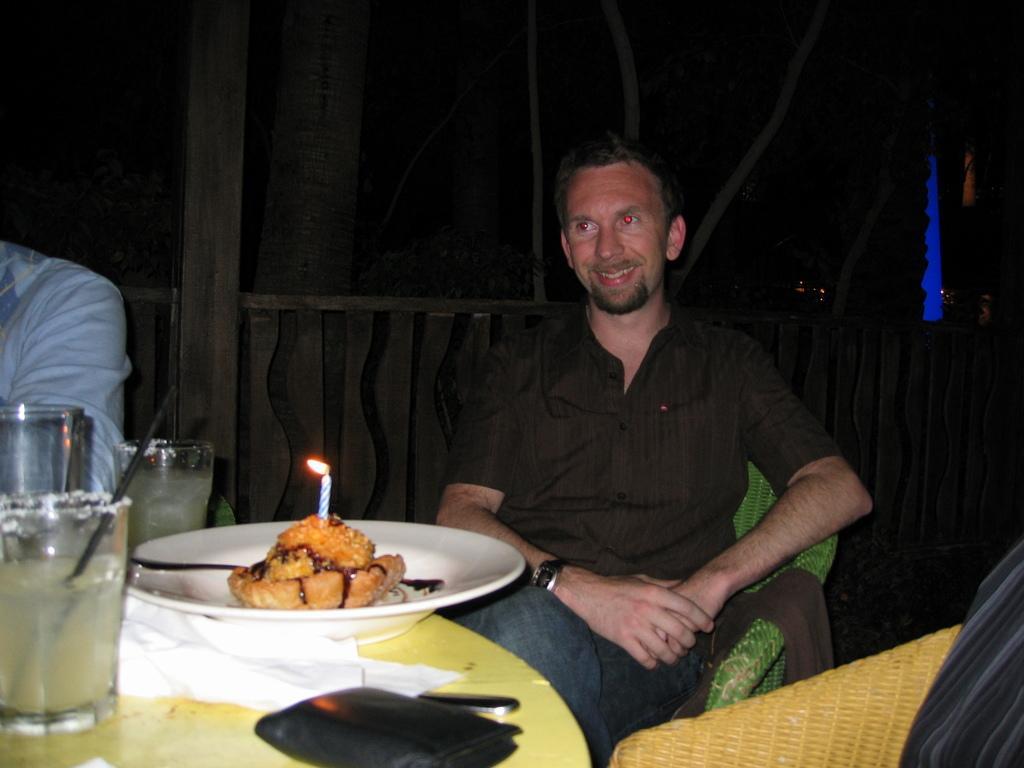Can you describe this image briefly? In this image i can see a person sitting on a chair in front of a table. On the table i can see a plate with a food item in it, a glass and a wallet. 